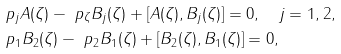<formula> <loc_0><loc_0><loc_500><loc_500>& \ p _ { j } A ( \zeta ) - \ p _ { \zeta } B _ { j } ( \zeta ) + [ A ( \zeta ) , B _ { j } ( \zeta ) ] = 0 , \quad j = 1 , 2 , \\ & \ p _ { 1 } B _ { 2 } ( \zeta ) - \ p _ { 2 } B _ { 1 } ( \zeta ) + [ B _ { 2 } ( \zeta ) , B _ { 1 } ( \zeta ) ] = 0 ,</formula> 